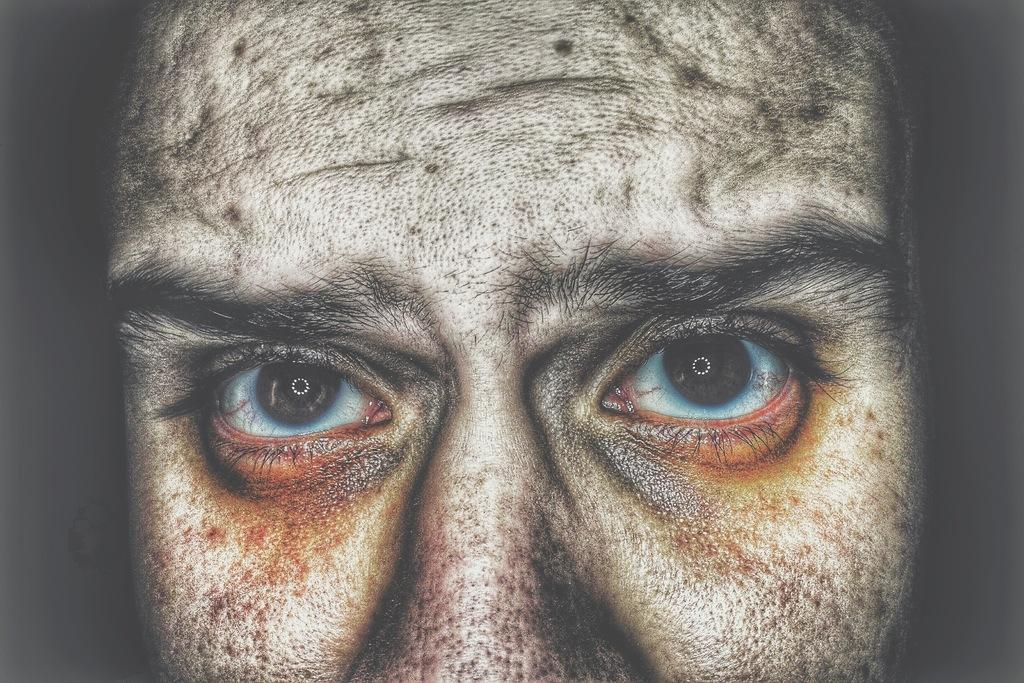What can be said about the nature of the image? The image is edited. Who is present in the image? There is a man in the image. What is the man doing in the image? The man is looking at the side. What type of air is being tested in the image? There is no indication of any air or testing in the image; it features a man looking at the side. 